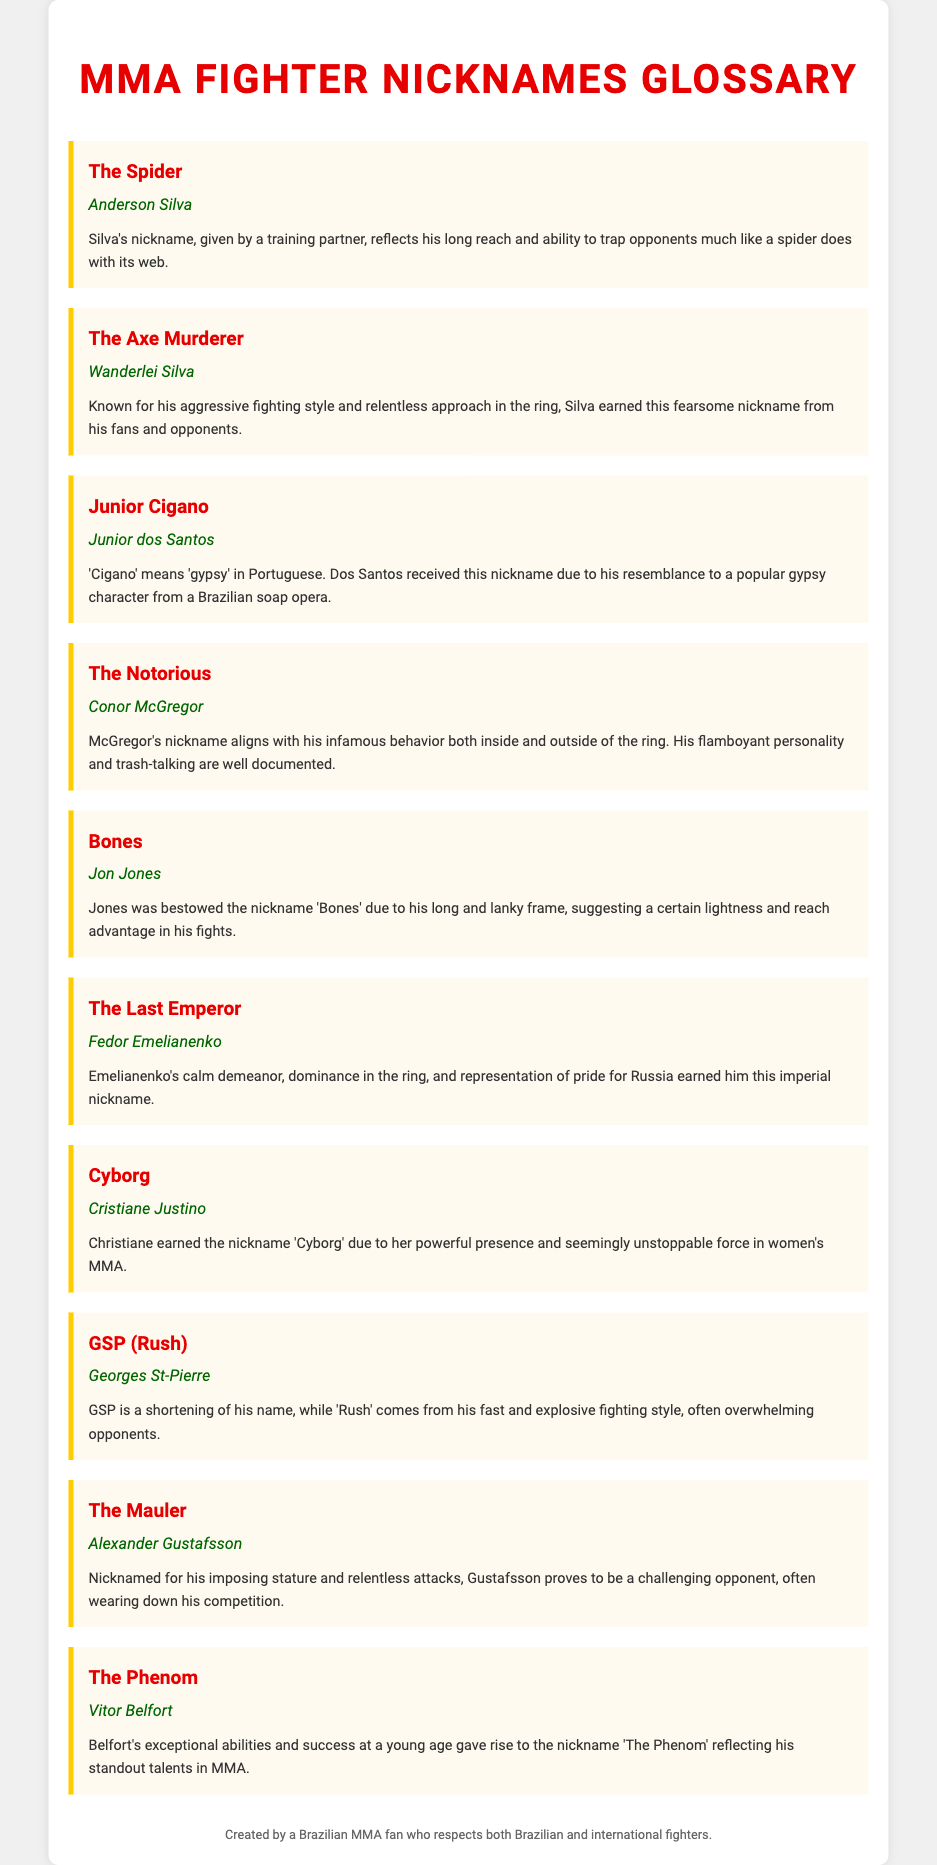What is Anderson Silva's nickname? The nickname listed for Anderson Silva in the document is "The Spider."
Answer: The Spider Who is known as "The Axe Murderer"? "The Axe Murderer" is the nickname for Wanderlei Silva mentioned in the document.
Answer: Wanderlei Silva What does "Cigano" mean in Portuguese? The document states that "Cigano" means "gypsy" in Portuguese, referring to Junior dos Santos.
Answer: gypsy Who received the nickname "The Last Emperor"? Fedor Emelianenko is identified as "The Last Emperor" in the glossary.
Answer: Fedor Emelianenko Why was Jon Jones nicknamed "Bones"? The reason given in the document for Jon Jones being nicknamed "Bones" is due to his long and lanky frame.
Answer: long and lanky frame What nickname is associated with Georges St-Pierre? The glossary lists "GSP (Rush)" as the nickname associated with Georges St-Pierre.
Answer: GSP (Rush) Which fighter is referred to as "Cyborg"? The nickname "Cyborg" refers to Cristiane Justino, as stated in the document.
Answer: Cristiane Justino What characteristic led to Vitor Belfort being called "The Phenom"? The document attributes the nickname "The Phenom" to Belfort's exceptional abilities and success at a young age.
Answer: exceptional abilities and success at a young age Which fighter has the nickname reflecting an aggressive fighting style? The nickname showing an aggressive fighting style mentioned in the document is "The Axe Murderer," associated with Wanderlei Silva.
Answer: The Axe Murderer 